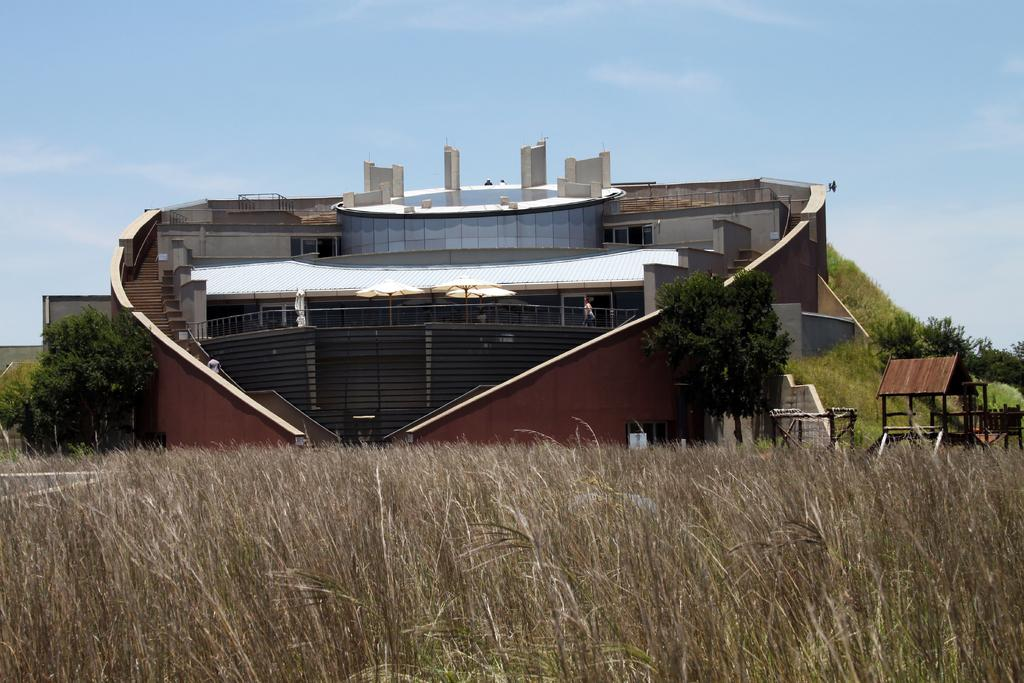What type of structure is present in the image? There is a building in the image. What other type of structure can be seen in the image? There is a shelter in the image. What type of vegetation is visible in the image? There is grass and trees in the image. What is visible in the background of the image? The sky is visible in the background of the image. What items are on the list that the mother is holding in the image? There is no mother or list present in the image. 